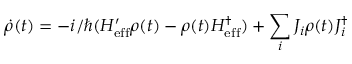<formula> <loc_0><loc_0><loc_500><loc_500>\dot { \rho } ( t ) = - i / \hbar { ( } H _ { e f f } ^ { \prime } \rho ( t ) - \rho ( t ) H _ { e f f } ^ { \dagger } ) + \sum _ { i } J _ { i } \rho ( t ) J _ { i } ^ { \dagger }</formula> 